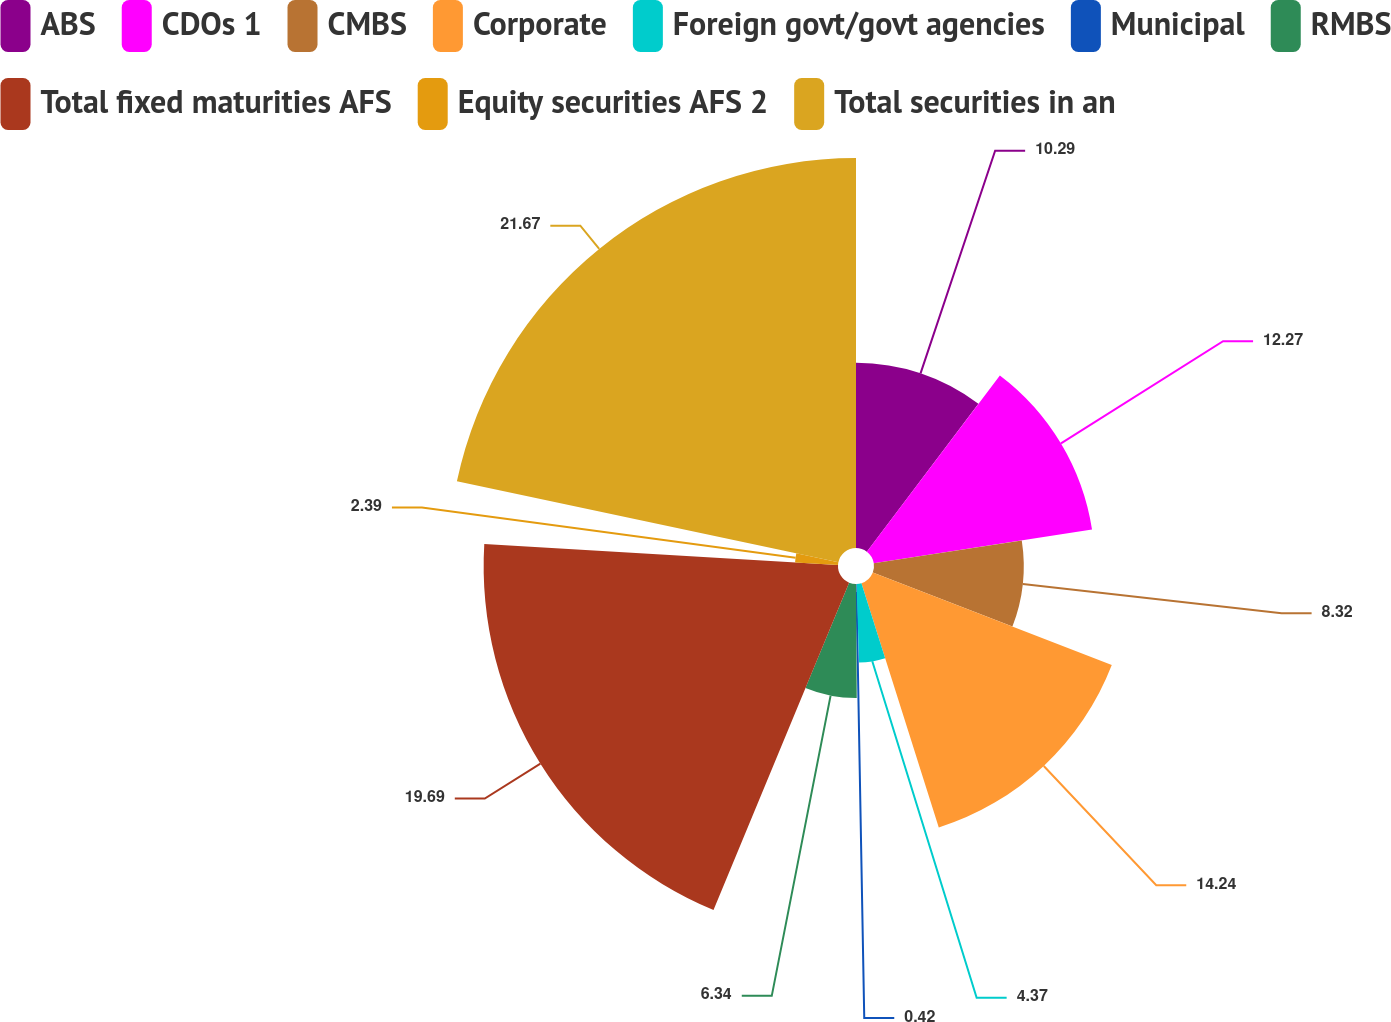Convert chart. <chart><loc_0><loc_0><loc_500><loc_500><pie_chart><fcel>ABS<fcel>CDOs 1<fcel>CMBS<fcel>Corporate<fcel>Foreign govt/govt agencies<fcel>Municipal<fcel>RMBS<fcel>Total fixed maturities AFS<fcel>Equity securities AFS 2<fcel>Total securities in an<nl><fcel>10.29%<fcel>12.27%<fcel>8.32%<fcel>14.24%<fcel>4.37%<fcel>0.42%<fcel>6.34%<fcel>19.69%<fcel>2.39%<fcel>21.67%<nl></chart> 